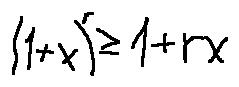<formula> <loc_0><loc_0><loc_500><loc_500>( 1 + x ) ^ { r } \geq 1 + r x</formula> 